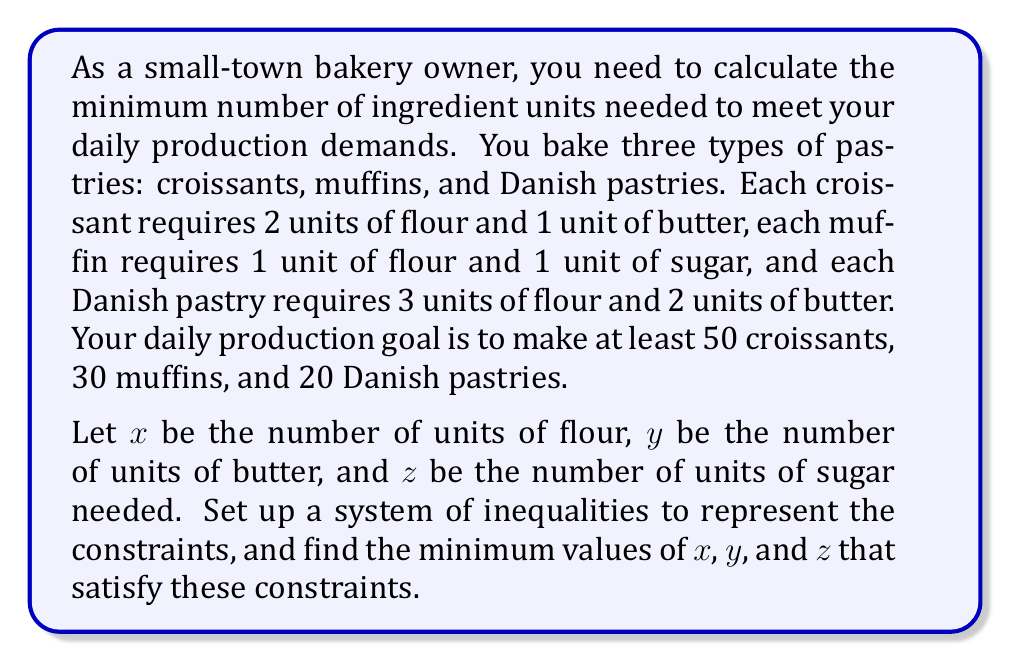Solve this math problem. Let's approach this problem step by step:

1) First, let's set up the inequalities based on the given information:

   For flour (x): $2(50) + 1(30) + 3(20) \leq x$
   For butter (y): $1(50) + 2(20) \leq y$
   For sugar (z): $1(30) \leq z$

2) Let's simplify these inequalities:

   $100 + 30 + 60 \leq x$, which simplifies to $190 \leq x$
   $50 + 40 \leq y$, which simplifies to $90 \leq y$
   $30 \leq z$

3) Since we're looking for the minimum values that satisfy these inequalities, we can convert these to equations:

   $x = 190$
   $y = 90$
   $z = 30$

4) These values represent the minimum number of units needed for each ingredient to meet the daily production demands.

5) To verify, let's check if these values satisfy our original production requirements:

   Croissants: 50 * (2 flour + 1 butter) = 100 flour + 50 butter
   Muffins: 30 * (1 flour + 1 sugar) = 30 flour + 30 sugar
   Danish: 20 * (3 flour + 2 butter) = 60 flour + 40 butter

   Total flour used: 100 + 30 + 60 = 190 units
   Total butter used: 50 + 40 = 90 units
   Total sugar used: 30 units

   These match our calculated minimum values.
Answer: The minimum number of ingredient units needed are:
$x = 190$ units of flour
$y = 90$ units of butter
$z = 30$ units of sugar 